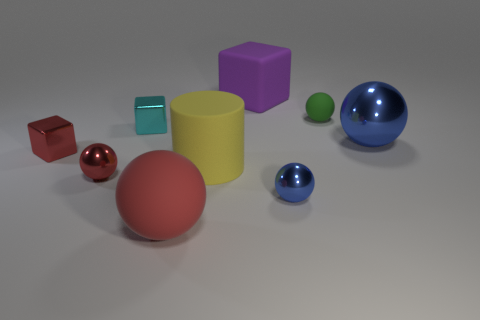What number of objects are small red cylinders or things that are on the left side of the tiny cyan cube?
Provide a short and direct response. 2. There is a big thing behind the big ball that is behind the big red matte thing; how many big blue shiny balls are to the left of it?
Provide a succinct answer. 0. There is a purple cube that is the same size as the yellow thing; what material is it?
Provide a succinct answer. Rubber. Is there another yellow object of the same size as the yellow thing?
Your answer should be very brief. No. What color is the big rubber cylinder?
Your answer should be very brief. Yellow. There is a matte sphere that is right of the big ball on the left side of the matte block; what color is it?
Provide a succinct answer. Green. The large rubber thing that is left of the large yellow cylinder left of the big ball behind the big red object is what shape?
Your answer should be compact. Sphere. How many green objects have the same material as the tiny blue thing?
Ensure brevity in your answer.  0. What number of tiny shiny things are left of the tiny metal object that is behind the red shiny cube?
Ensure brevity in your answer.  2. What number of big blue rubber cylinders are there?
Provide a succinct answer. 0. 